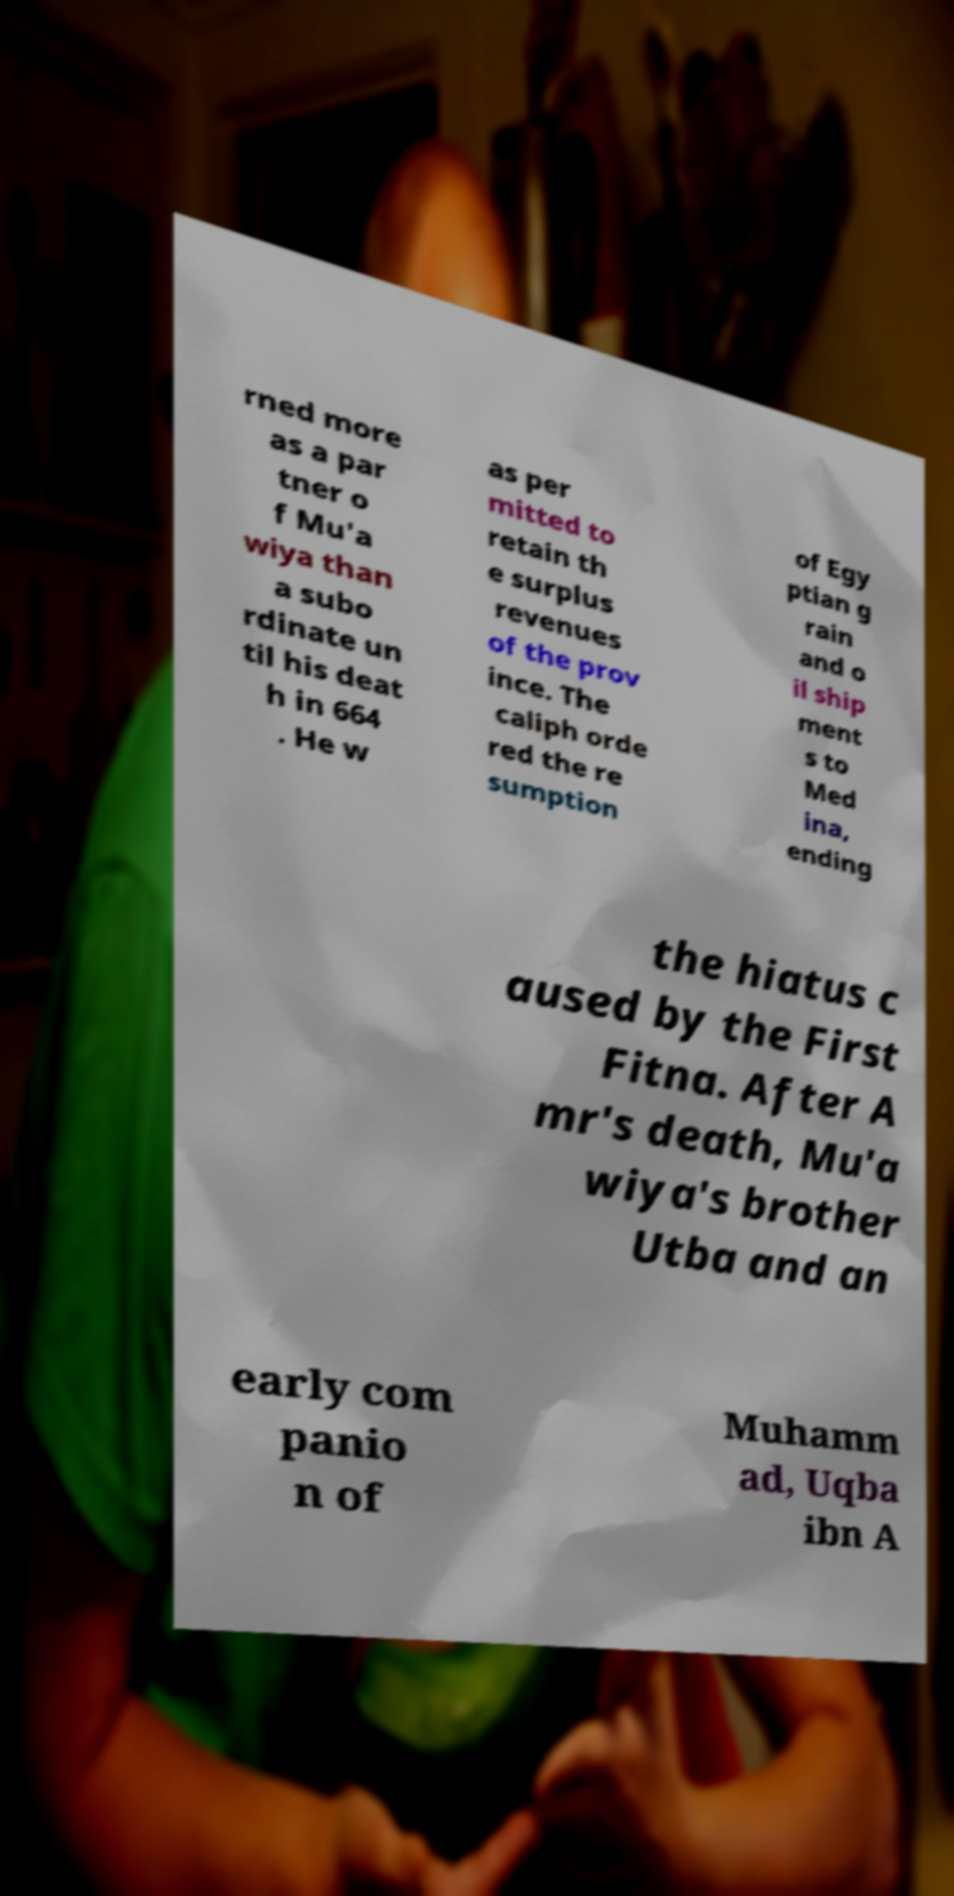There's text embedded in this image that I need extracted. Can you transcribe it verbatim? rned more as a par tner o f Mu'a wiya than a subo rdinate un til his deat h in 664 . He w as per mitted to retain th e surplus revenues of the prov ince. The caliph orde red the re sumption of Egy ptian g rain and o il ship ment s to Med ina, ending the hiatus c aused by the First Fitna. After A mr's death, Mu'a wiya's brother Utba and an early com panio n of Muhamm ad, Uqba ibn A 